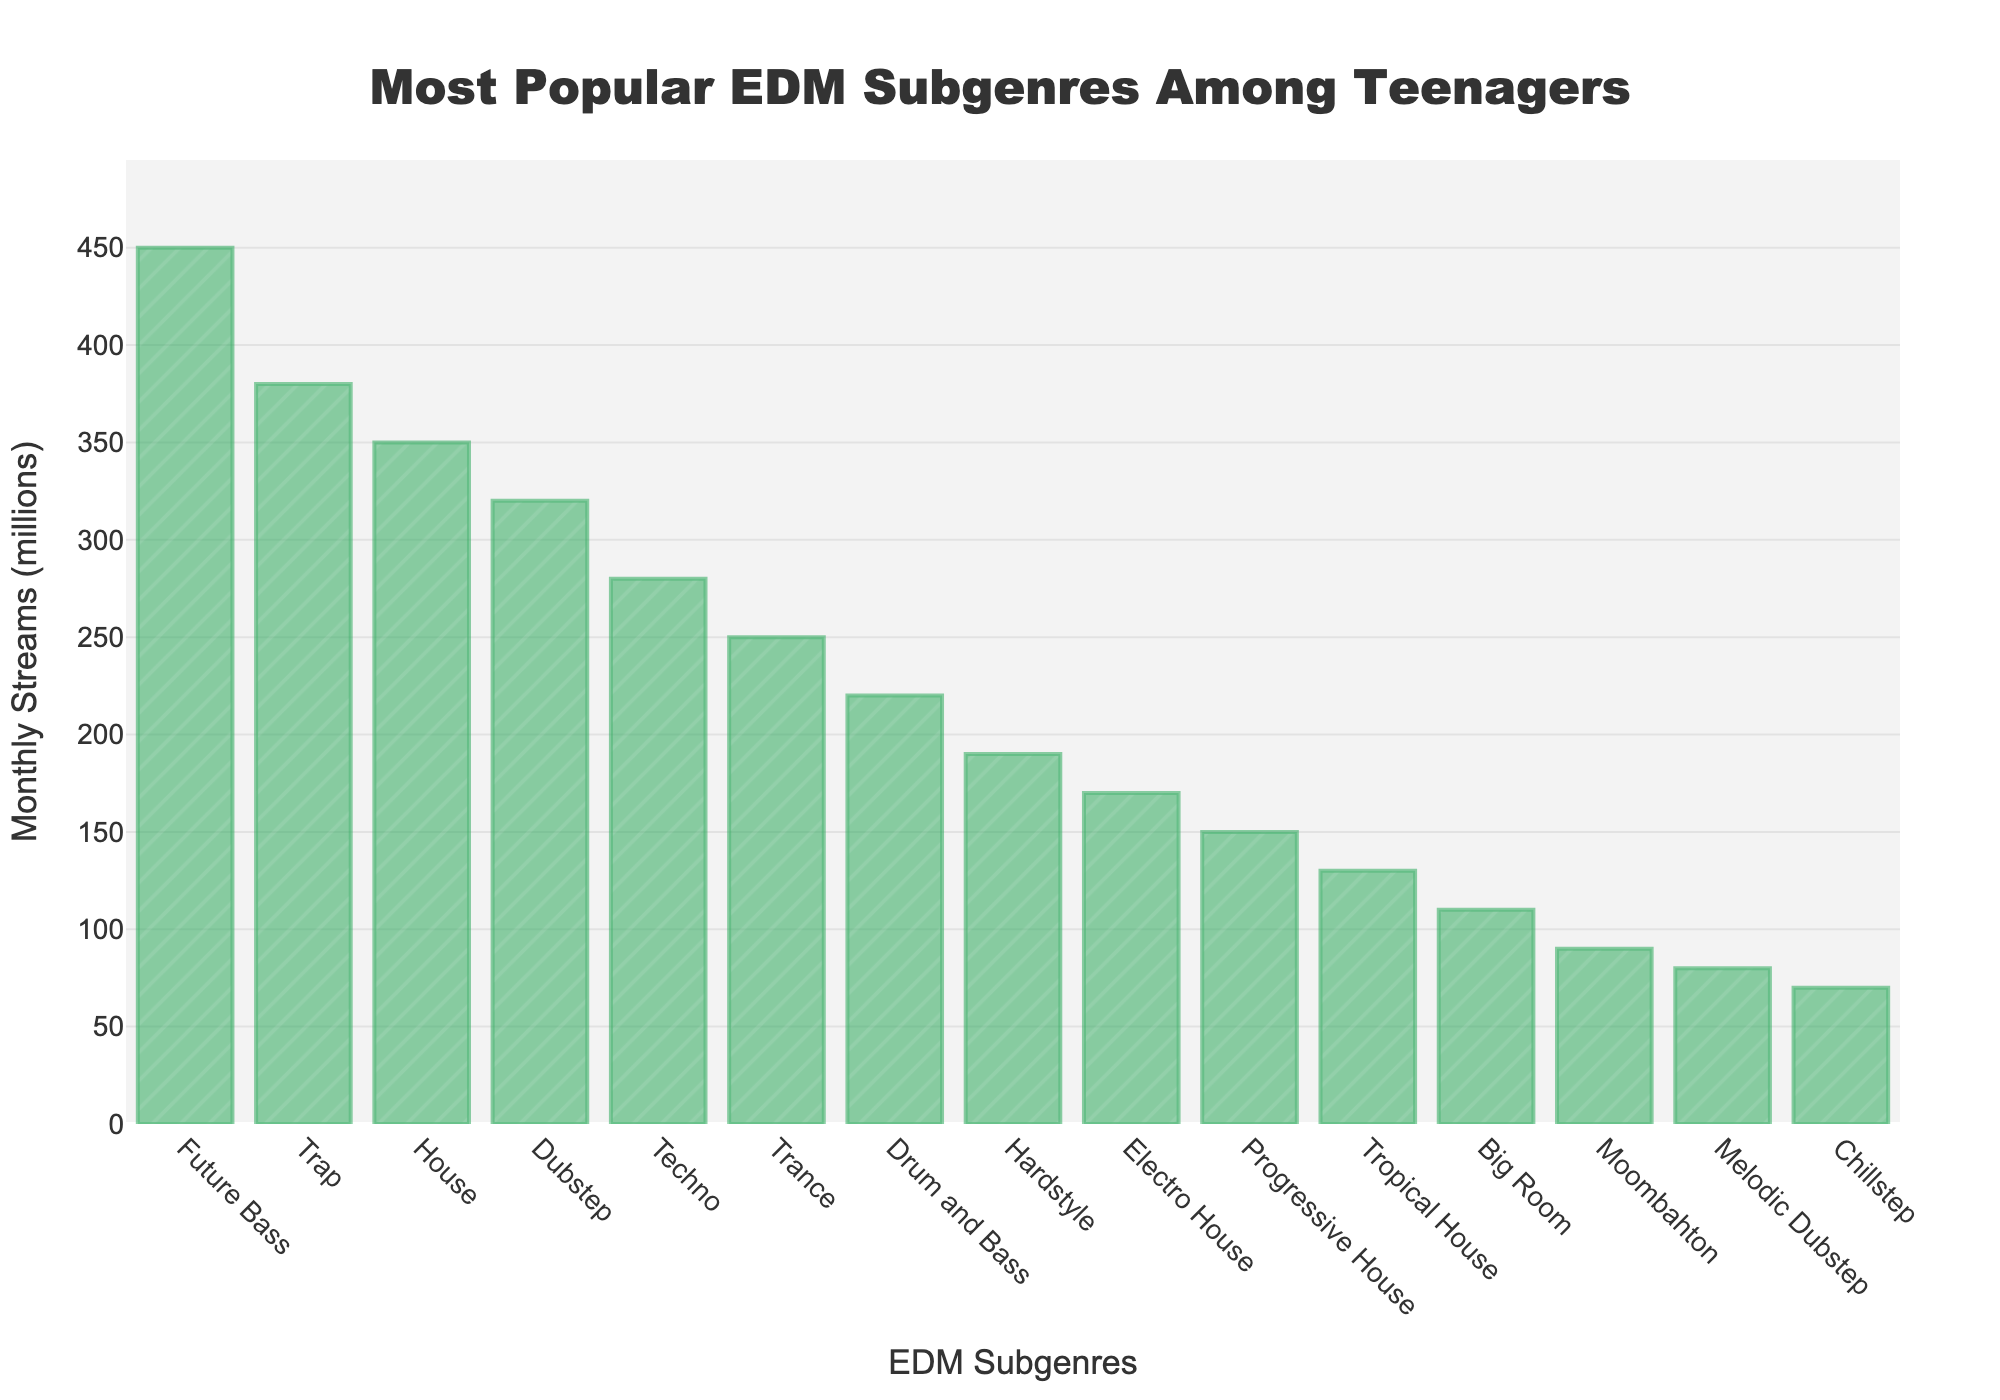Which EDM subgenre has the most monthly streams? The subgenre with the highest bar in the graph represents the one with the most monthly streams. In this case, it is "Future Bass".
Answer: Future Bass What is the difference in monthly streams between Trap and Techno? First, find the monthly streams for Trap (380 million) and Techno (280 million). Then, subtract the smaller number from the larger: 380 - 280 = 100 million.
Answer: 100 million Which subgenre has fewer monthly streams than Drum and Bass but more than Electro House? Identify the monthly streams for Drum and Bass (220 million) and Electro House (170 million). The subgenre between these values is Hardstyle with 190 million monthly streams.
Answer: Hardstyle What is the sum of monthly streams for House and Dubstep? Find the monthly streams for House (350 million) and Dubstep (320 million). Add them together: 350 + 320 = 670 million.
Answer: 670 million Which subgenre has the closest monthly streams to the median value? List the values in ascending order and find the middle value. The median of the dataset will be the value at the 8th position of a sorted list (since there are 15 subgenres). The median value here is for Hardstyle which has 190 million streams.
Answer: Hardstyle How many subgenres have more than 300 million monthly streams? Count the bars whose height represents more than 300 million. Future Bass, Trap, House, and Dubstep each have more than 300 million monthly streams, making it 4 subgenres.
Answer: 4 Which subgenre has twice the monthly streams of Progressive House? Identify the monthly streams for Progressive House (150 million). Double it to get 300 million. Among the subgenres, Dubstep has 320 million monthly streams, which is the closest but slightly above 300 million.
Answer: Dubstep By how much do the monthly streams for Tropical House exceed those of Chillstep? Find the monthly streams for both Tropical House (130 million) and Chillstep (70 million). Subtract the smaller number from the larger: 130 - 70 = 60 million.
Answer: 60 million Arrange the top three subgenres based on their monthly streams in descending order. Identify the top three subgenres by their stream numbers, Future Bass (450 million), Trap (380 million), and House (350 million). List them from highest to lowest.
Answer: Future Bass, Trap, House What is the average monthly stream count for the bottom three subgenres? Find the monthly streams for the bottom three subgenres: Melodic Dubstep (80 million), Chillstep (70 million), and Moombahton (90 million). Calculate the average: (80 + 70 + 90) / 3 = 240 / 3 = 80 million.
Answer: 80 million 